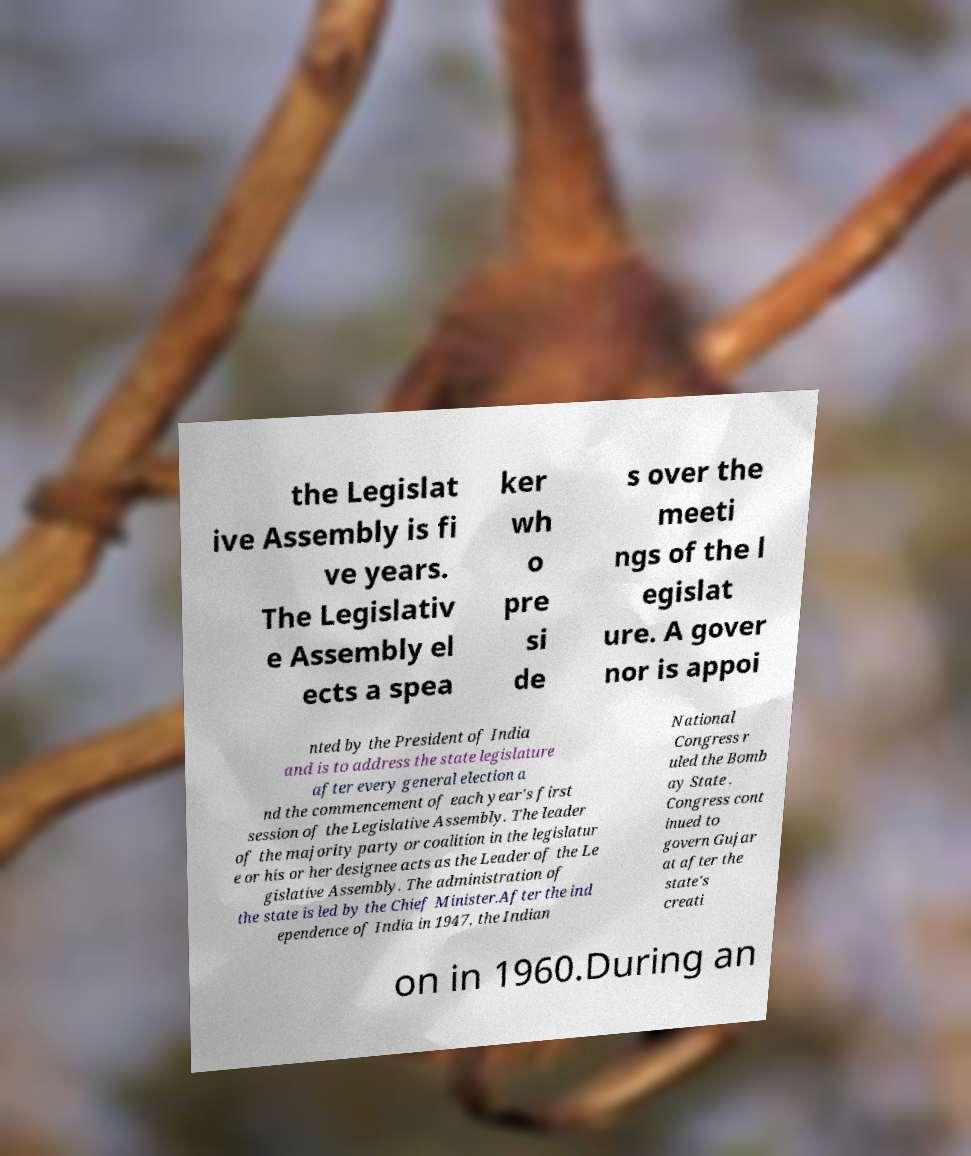Could you extract and type out the text from this image? the Legislat ive Assembly is fi ve years. The Legislativ e Assembly el ects a spea ker wh o pre si de s over the meeti ngs of the l egislat ure. A gover nor is appoi nted by the President of India and is to address the state legislature after every general election a nd the commencement of each year's first session of the Legislative Assembly. The leader of the majority party or coalition in the legislatur e or his or her designee acts as the Leader of the Le gislative Assembly. The administration of the state is led by the Chief Minister.After the ind ependence of India in 1947, the Indian National Congress r uled the Bomb ay State . Congress cont inued to govern Gujar at after the state's creati on in 1960.During an 